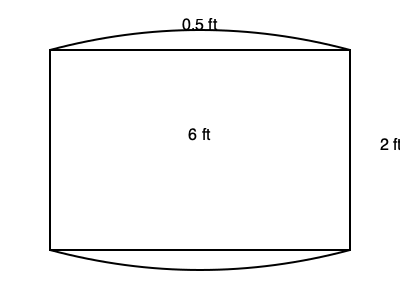You've designed a new surfboard with a unique shape to outperform your rival's standard boards. The board is rectangular with curved ends, as shown in the diagram. The main body is 6 ft long and 2 ft wide, with semicircular ends that add 0.5 ft to each end of the length. Calculate the total surface area of this surfboard in square feet, assuming both sides are identical. Round your answer to two decimal places. To calculate the surface area, we need to:
1. Find the area of the rectangular part:
   $A_{rect} = 6 \text{ ft} \times 2 \text{ ft} = 12 \text{ sq ft}$

2. Find the area of each semicircular end:
   Radius of semicircle: $r = 1 \text{ ft}$
   Area of one semicircle: $A_{semi} = \frac{1}{2} \times \pi r^2 = \frac{1}{2} \times \pi \times 1^2 = \frac{\pi}{2} \text{ sq ft}$

3. Calculate the total area of one side:
   $A_{one side} = A_{rect} + 2 \times A_{semi} = 12 + 2 \times \frac{\pi}{2} = 12 + \pi \text{ sq ft}$

4. Multiply by 2 for both sides of the board:
   $A_{total} = 2 \times A_{one side} = 2(12 + \pi) = 24 + 2\pi \text{ sq ft}$

5. Calculate and round to two decimal places:
   $A_{total} = 24 + 2 \times 3.14159... \approx 30.28 \text{ sq ft}$
Answer: 30.28 sq ft 